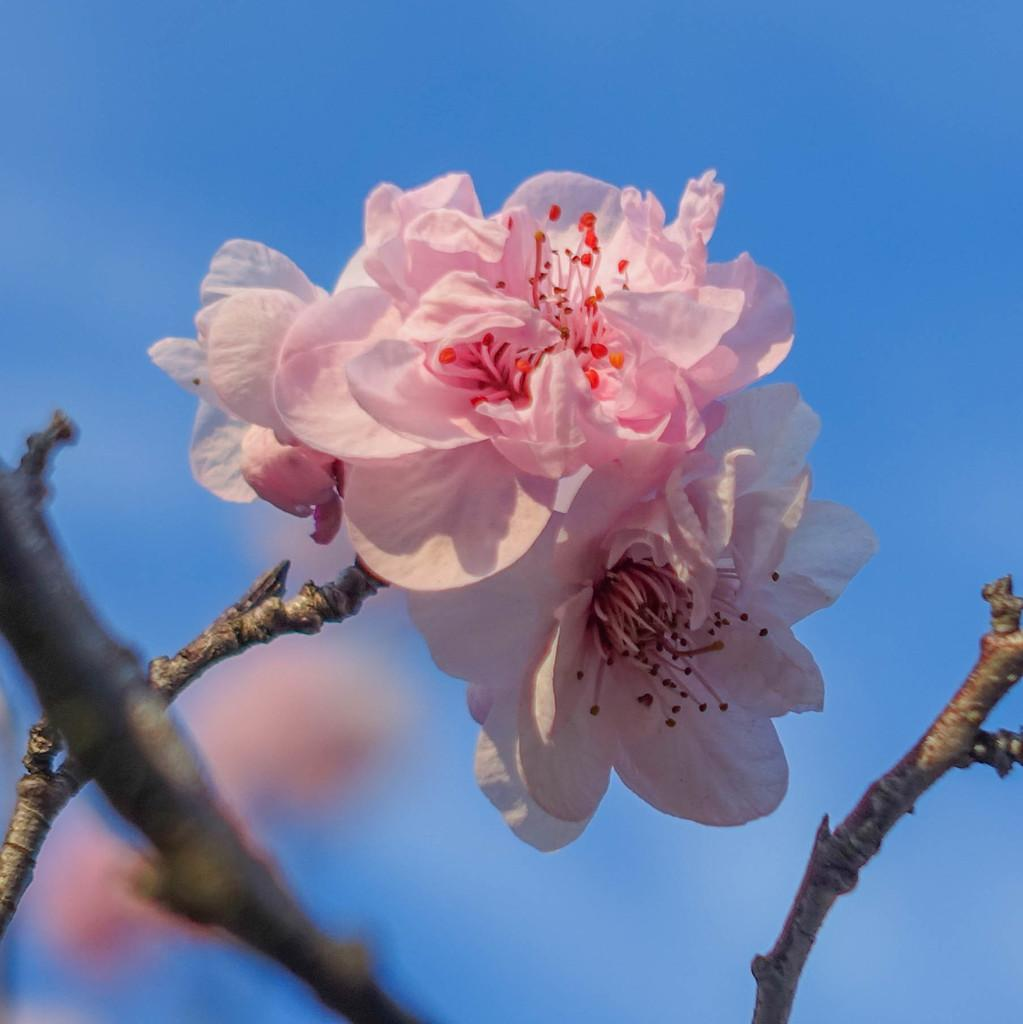What is the main subject of the image? There is a bunch of flowers in the image. What can be seen connected to the flowers? There are stems visible in the image. What is visible in the distance behind the flowers? There is a sky visible in the background of the image. Can you describe the appearance of the objects in the background? There are blurred things in the background of the image. How many bananas and apples are present in the image? There are no bananas or apples present in the image; it features a bunch of flowers. 